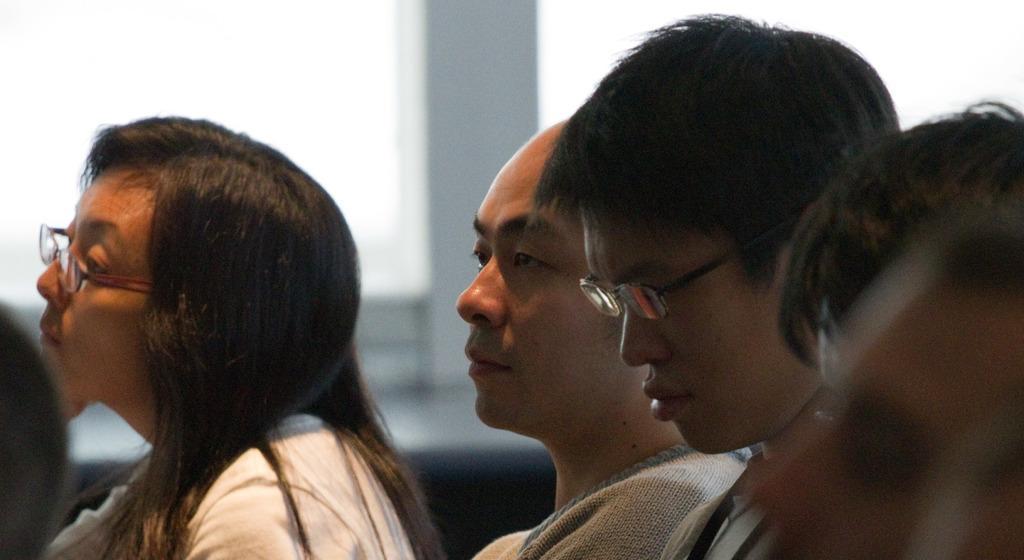Can you describe this image briefly? In this image, I can see one woman and two men. This woman and the man wore spectacles. 